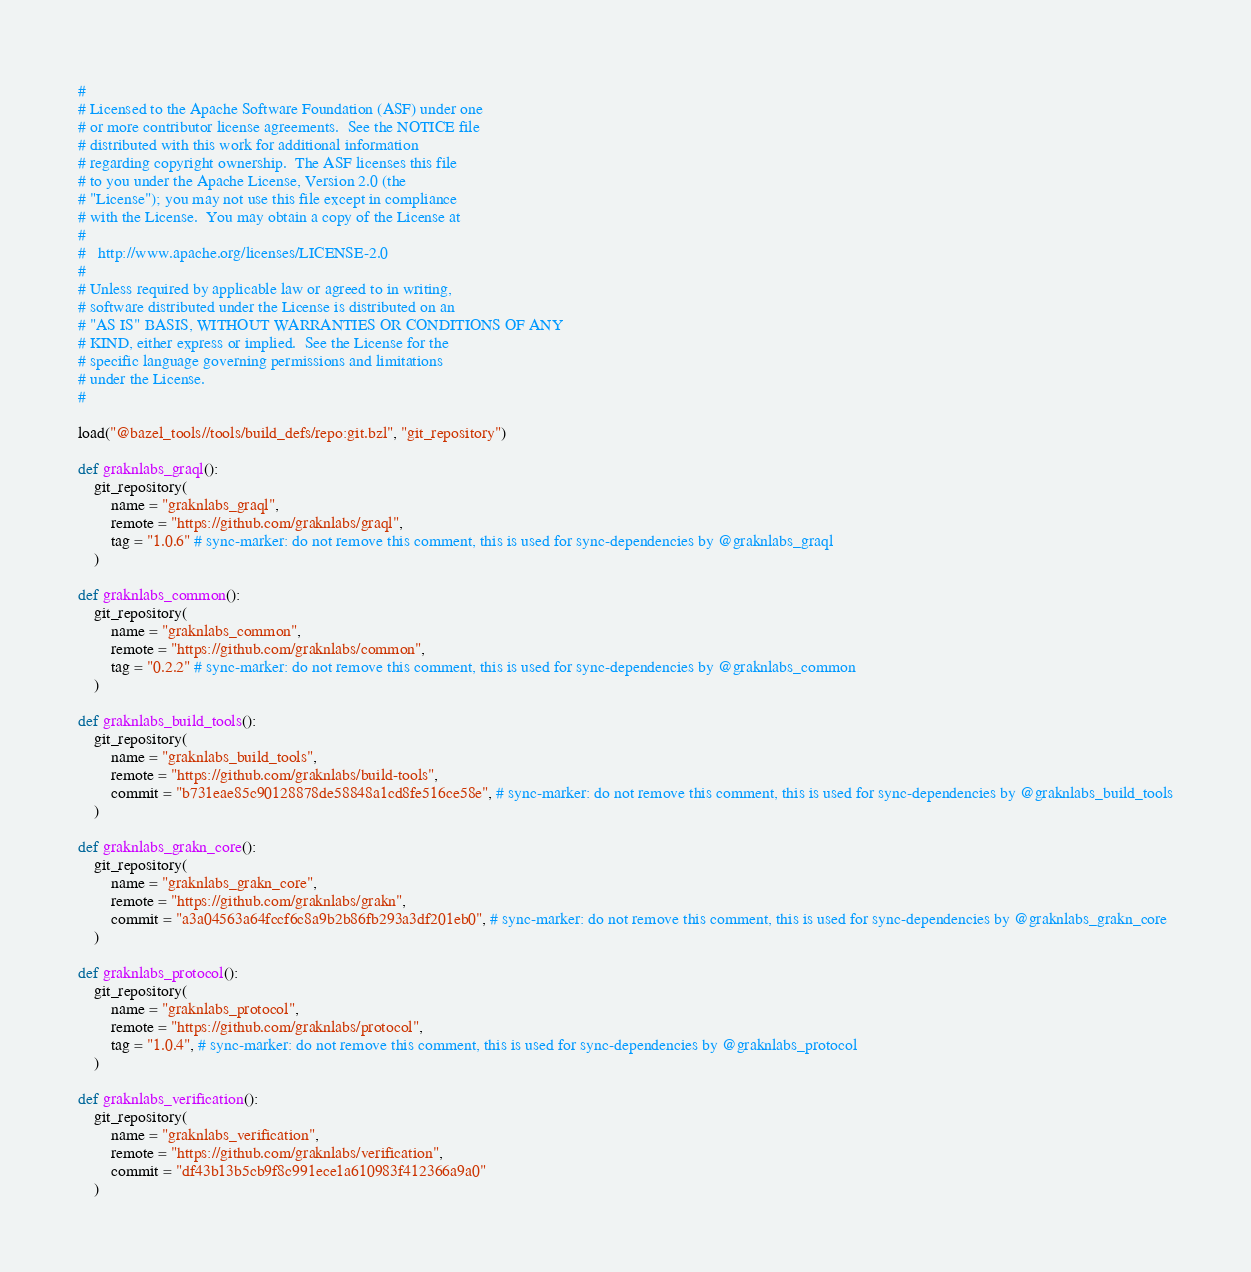<code> <loc_0><loc_0><loc_500><loc_500><_Python_>#
# Licensed to the Apache Software Foundation (ASF) under one
# or more contributor license agreements.  See the NOTICE file
# distributed with this work for additional information
# regarding copyright ownership.  The ASF licenses this file
# to you under the Apache License, Version 2.0 (the
# "License"); you may not use this file except in compliance
# with the License.  You may obtain a copy of the License at
#
#   http://www.apache.org/licenses/LICENSE-2.0
#
# Unless required by applicable law or agreed to in writing,
# software distributed under the License is distributed on an
# "AS IS" BASIS, WITHOUT WARRANTIES OR CONDITIONS OF ANY
# KIND, either express or implied.  See the License for the
# specific language governing permissions and limitations
# under the License.
#

load("@bazel_tools//tools/build_defs/repo:git.bzl", "git_repository")

def graknlabs_graql():
    git_repository(
        name = "graknlabs_graql",
        remote = "https://github.com/graknlabs/graql",
        tag = "1.0.6" # sync-marker: do not remove this comment, this is used for sync-dependencies by @graknlabs_graql
    )

def graknlabs_common():
    git_repository(
        name = "graknlabs_common",
        remote = "https://github.com/graknlabs/common",
        tag = "0.2.2" # sync-marker: do not remove this comment, this is used for sync-dependencies by @graknlabs_common
    )

def graknlabs_build_tools():
    git_repository(
        name = "graknlabs_build_tools",
        remote = "https://github.com/graknlabs/build-tools",
        commit = "b731eae85c90128878de58848a1cd8fe516ce58e", # sync-marker: do not remove this comment, this is used for sync-dependencies by @graknlabs_build_tools
    )

def graknlabs_grakn_core():
    git_repository(
        name = "graknlabs_grakn_core",
        remote = "https://github.com/graknlabs/grakn",
        commit = "a3a04563a64fccf6c8a9b2b86fb293a3df201eb0", # sync-marker: do not remove this comment, this is used for sync-dependencies by @graknlabs_grakn_core
    )

def graknlabs_protocol():
    git_repository(
        name = "graknlabs_protocol",
        remote = "https://github.com/graknlabs/protocol",
        tag = "1.0.4", # sync-marker: do not remove this comment, this is used for sync-dependencies by @graknlabs_protocol
    )

def graknlabs_verification():
    git_repository(
        name = "graknlabs_verification",
        remote = "https://github.com/graknlabs/verification",
        commit = "df43b13b5cb9f8c991ece1a610983f412366a9a0"
    )</code> 